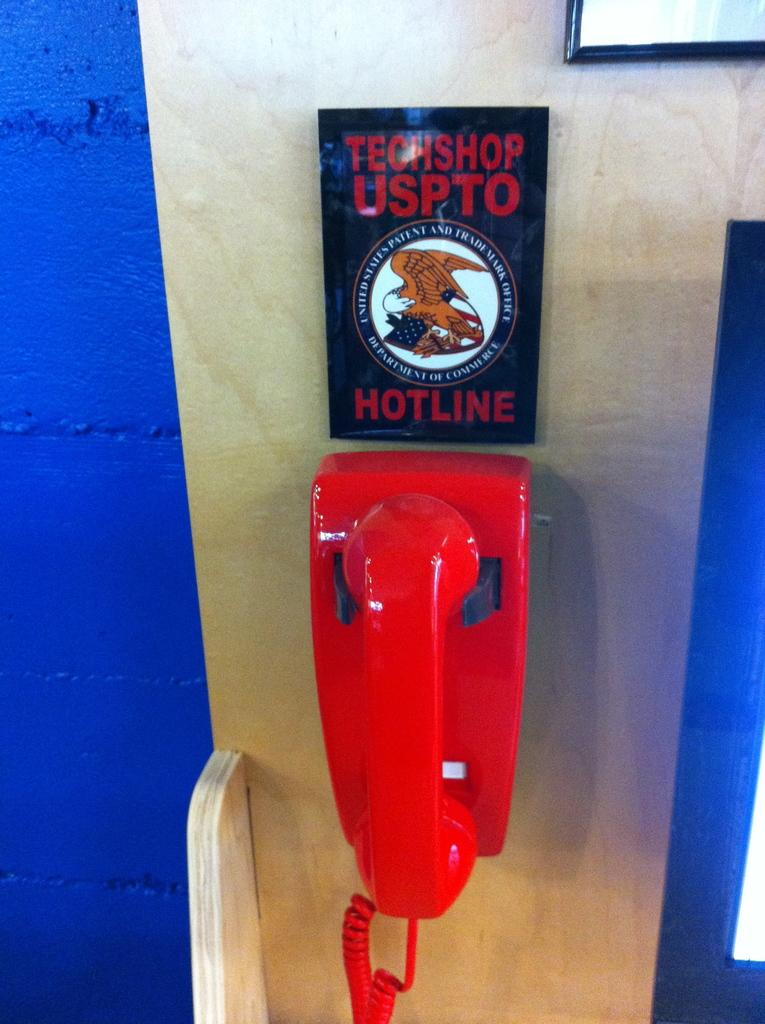<image>
Present a compact description of the photo's key features. An old fashoined red phone hangs on wall below a sign which says Technoshop Uspto Hotline. 